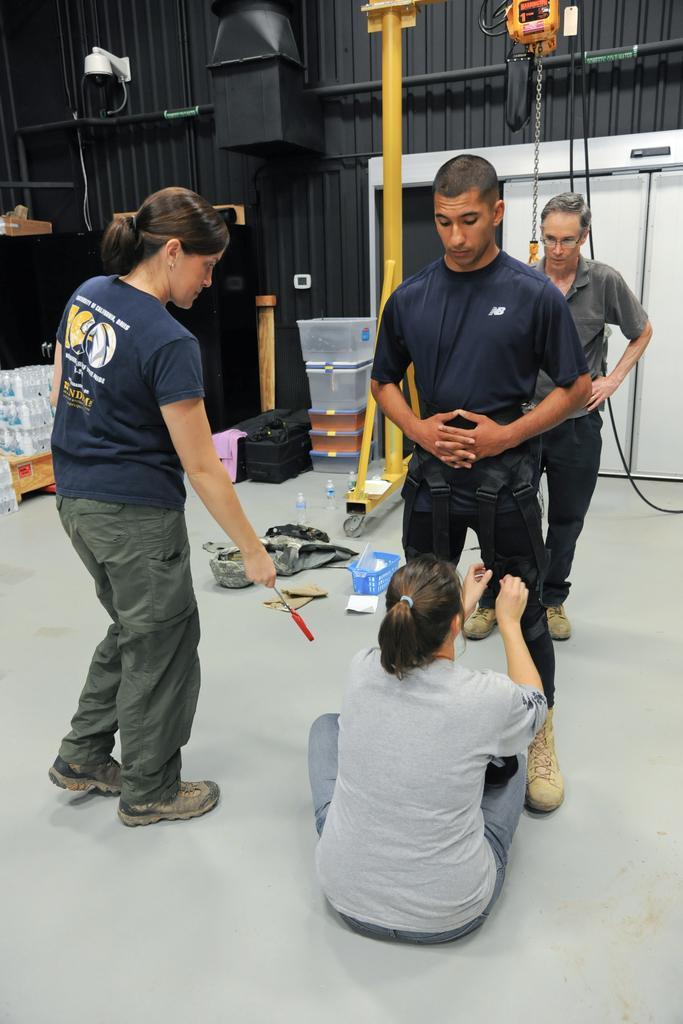Can you describe this image briefly? In this image there is a woman sitting on the floor and holding the pant of a man who is in front of her. At the top there are hangers to which there is a chain. On the left side there is another woman who is standing on the floor and giving the screwdriver to the woman. On the floor there are baskets,bags and trays. At the top left corner there is a webcam. 